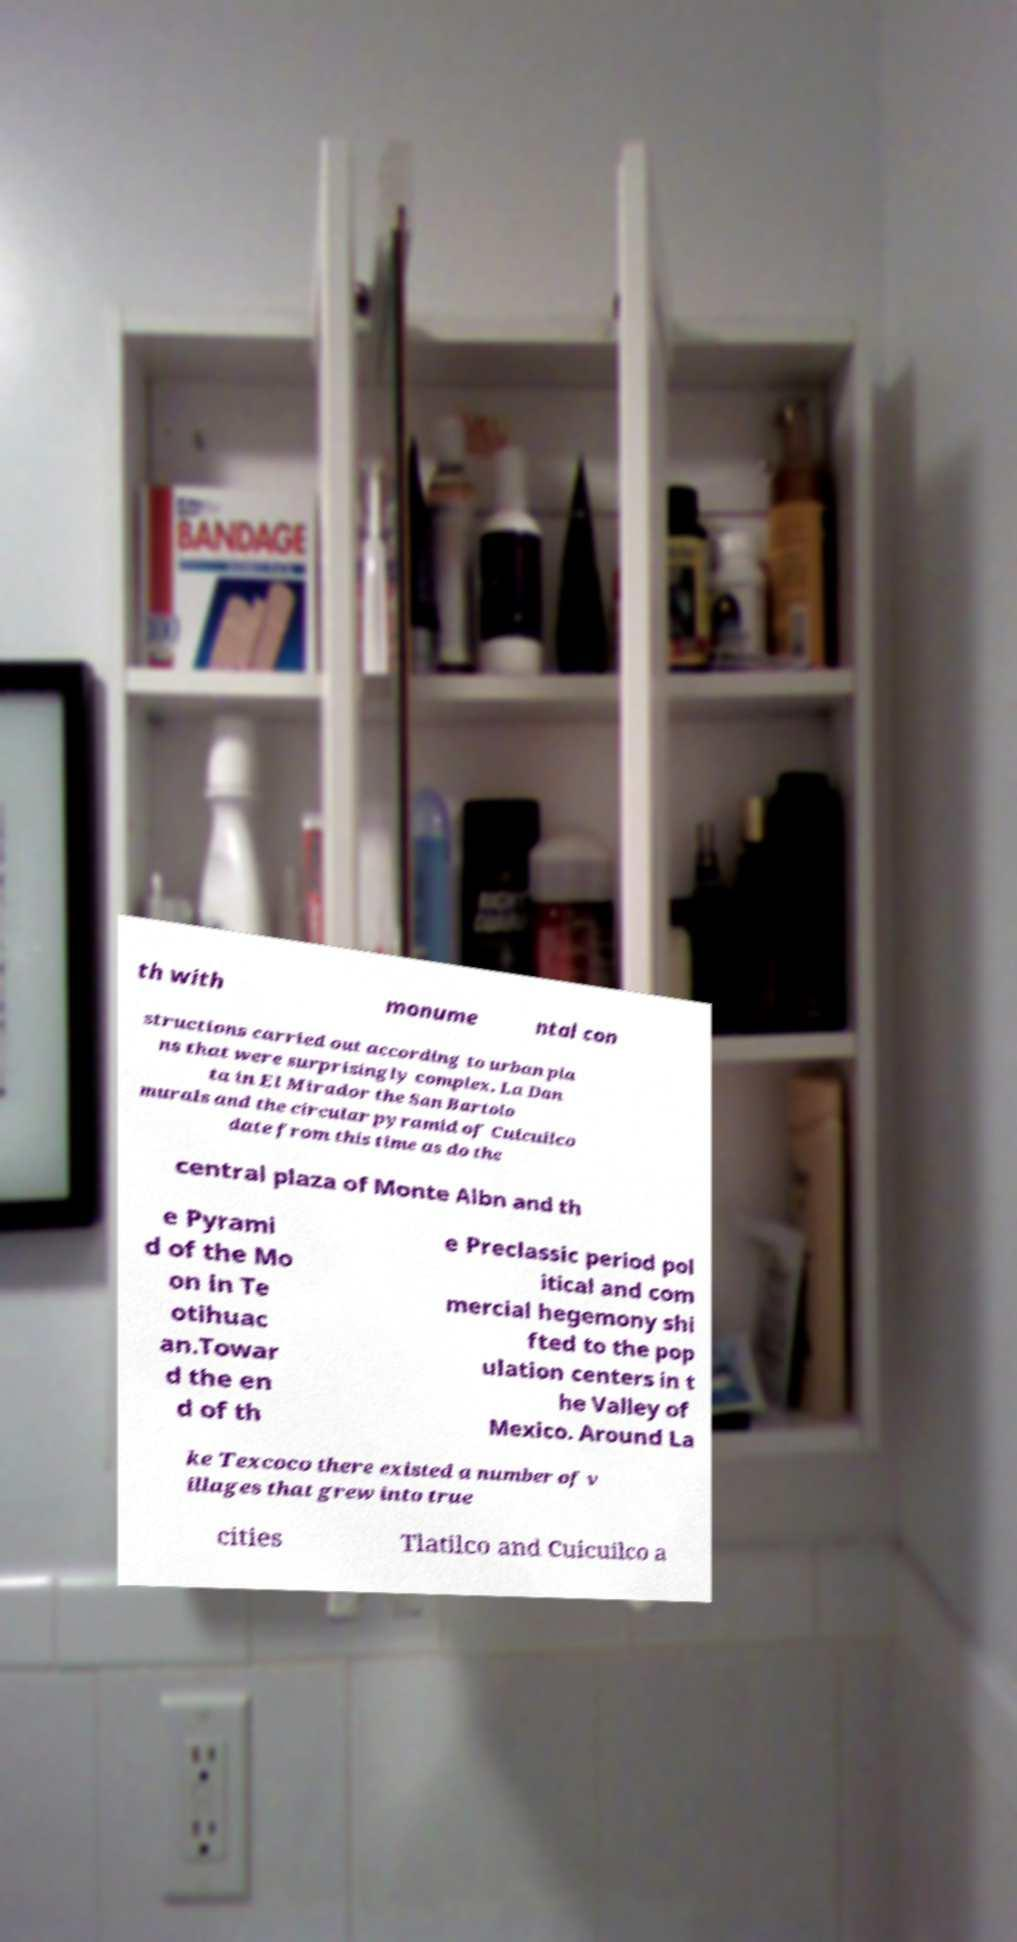What messages or text are displayed in this image? I need them in a readable, typed format. th with monume ntal con structions carried out according to urban pla ns that were surprisingly complex. La Dan ta in El Mirador the San Bartolo murals and the circular pyramid of Cuicuilco date from this time as do the central plaza of Monte Albn and th e Pyrami d of the Mo on in Te otihuac an.Towar d the en d of th e Preclassic period pol itical and com mercial hegemony shi fted to the pop ulation centers in t he Valley of Mexico. Around La ke Texcoco there existed a number of v illages that grew into true cities Tlatilco and Cuicuilco a 